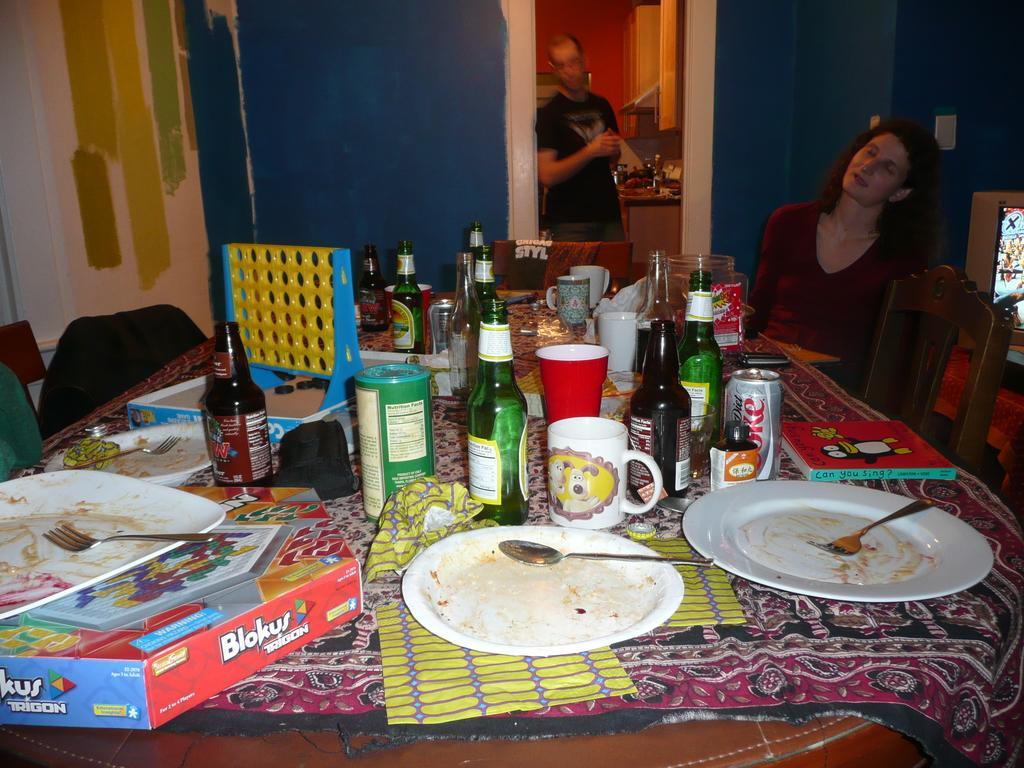Describe this image in one or two sentences. In this image I can see a dining table with bottles, glasses, cups, tins, plates, spoons, cloth, napkins on the table. I can see chairs and a woman sitting in a chair. I can see the TV on the right hand side. In the center to the top of the image I can see a door accessing the kitchen. I can see a person standing in the kitchen. 